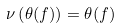<formula> <loc_0><loc_0><loc_500><loc_500>\nu \left ( \theta ( f ) \right ) = \theta ( f )</formula> 